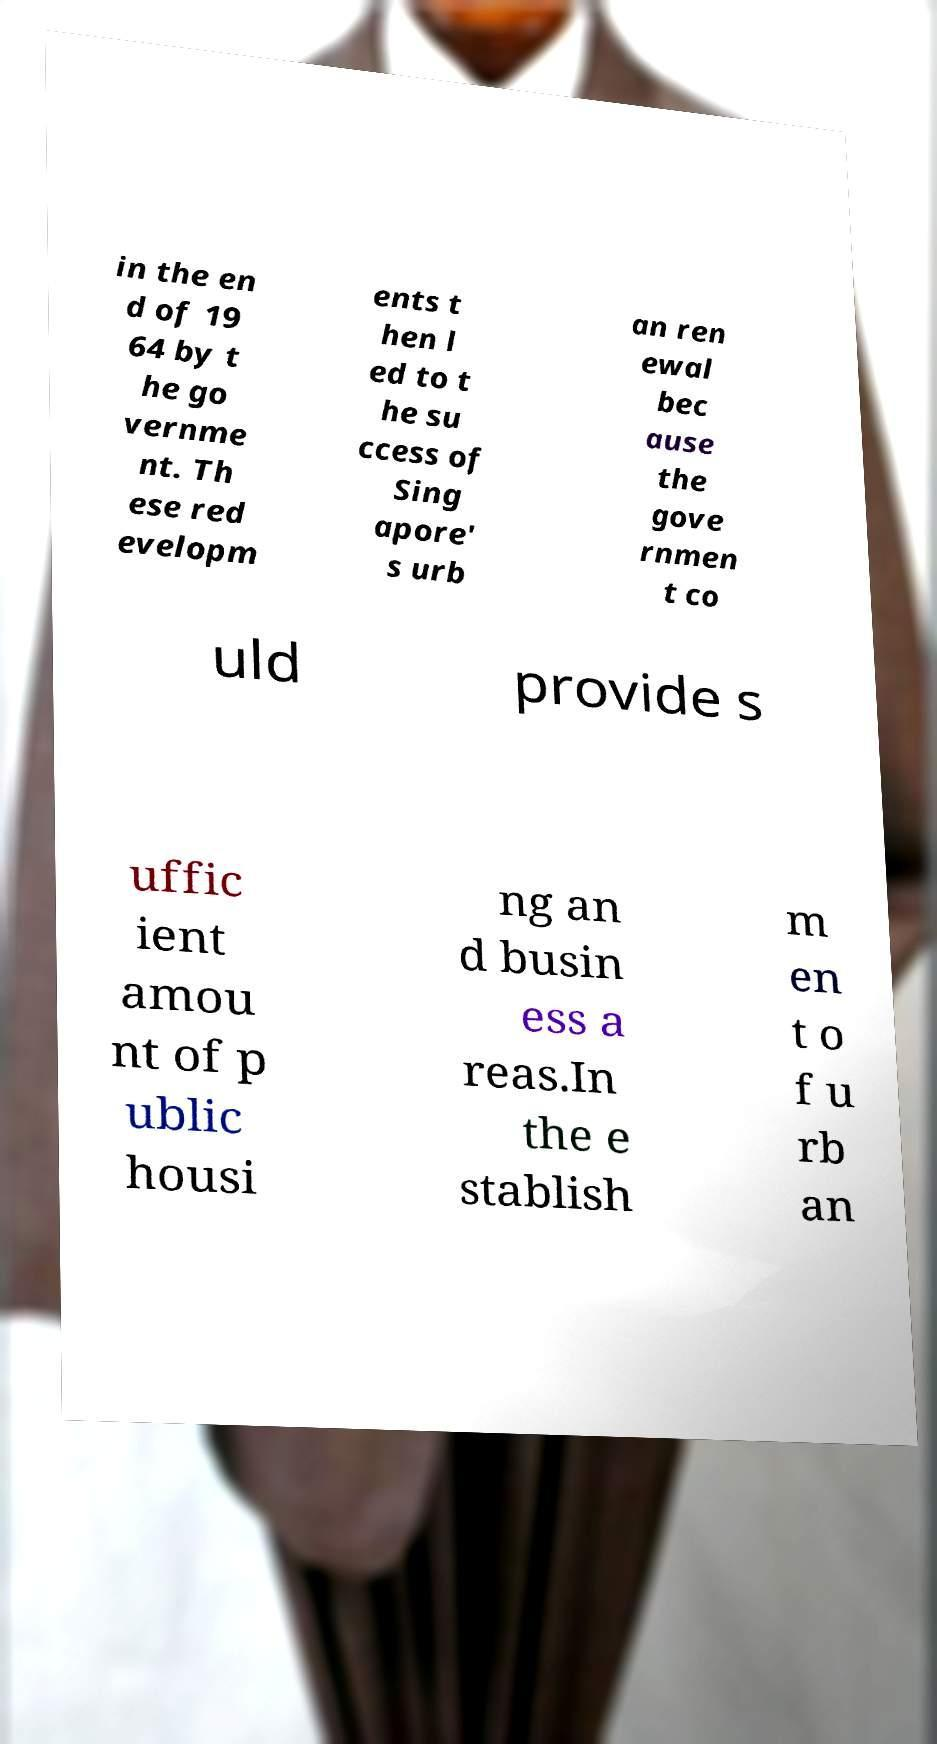Please read and relay the text visible in this image. What does it say? in the en d of 19 64 by t he go vernme nt. Th ese red evelopm ents t hen l ed to t he su ccess of Sing apore' s urb an ren ewal bec ause the gove rnmen t co uld provide s uffic ient amou nt of p ublic housi ng an d busin ess a reas.In the e stablish m en t o f u rb an 